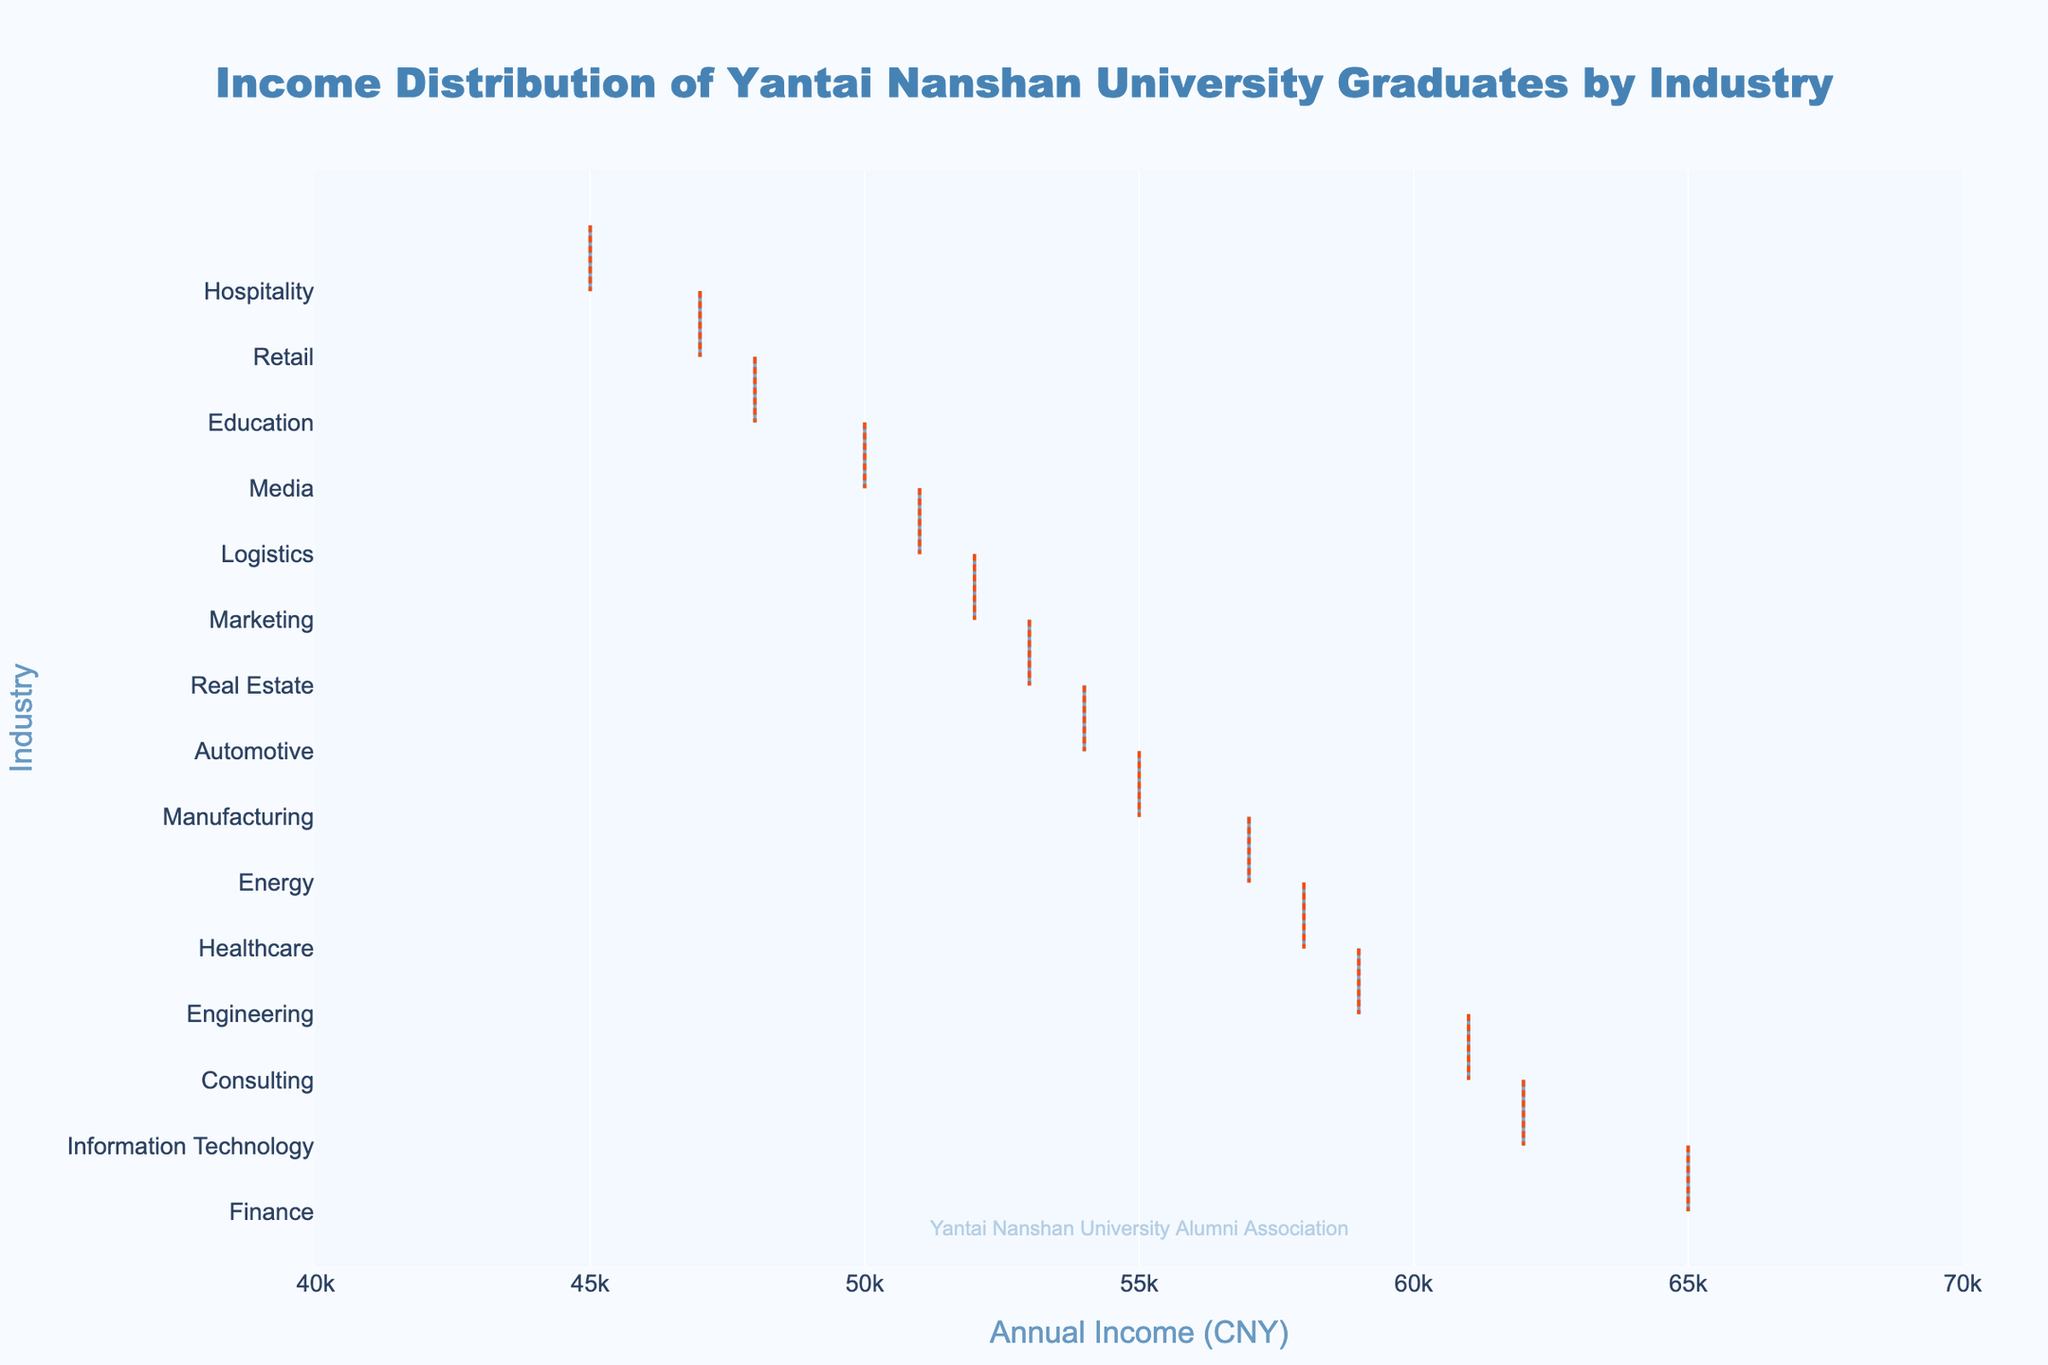What is the title of the plot? The title is located at the top center of the plot and describes what the plot is about.
Answer: Income Distribution of Yantai Nanshan University Graduates by Industry What is the highest income level represented in the plot? The highest income level can be identified by finding the longest horizontal density plot on the x-axis.
Answer: 65000 (Finance) Which industry has the lowest income level? The lowest income level can be seen by finding the shortest horizontal density plot on the x-axis.
Answer: Hospitality How many industries have an income level above 55000? To answer this, count the number of density plots where the income value (x-axis) is above 55000.
Answer: 6 Which industries have an income level close to 60000? Check for industries with income values close to 60000 on the x-axis within a small range.
Answer: Information Technology, Consulting, Engineering What is the range of income levels represented in the plot? The range can be determined by finding the difference between the highest and lowest incomes shown on the x-axis.
Answer: 20000 (65000 - 45000) Is there any industry with an income level exactly at 50000? Look along the x-axis for an income level of 50000 and note the corresponding industry.
Answer: Media Between Education and Healthcare, which industry has a higher income level? Compare the position of Education and Healthcare density plots on the x-axis.
Answer: Healthcare What is the average income level of the top five industries? Identify the top five industries by income levels, sum their income values, and divide by 5 (65000 + 62000 + 61000 + 59000 + 58000) / 5.
Answer: 61000 Does the plot indicate the presence of outliers for any industry? Check for any unusually spread-out or distinct points representing outliers in the density plots.
Answer: No outliers (as no points are indicated in the plot definition) 